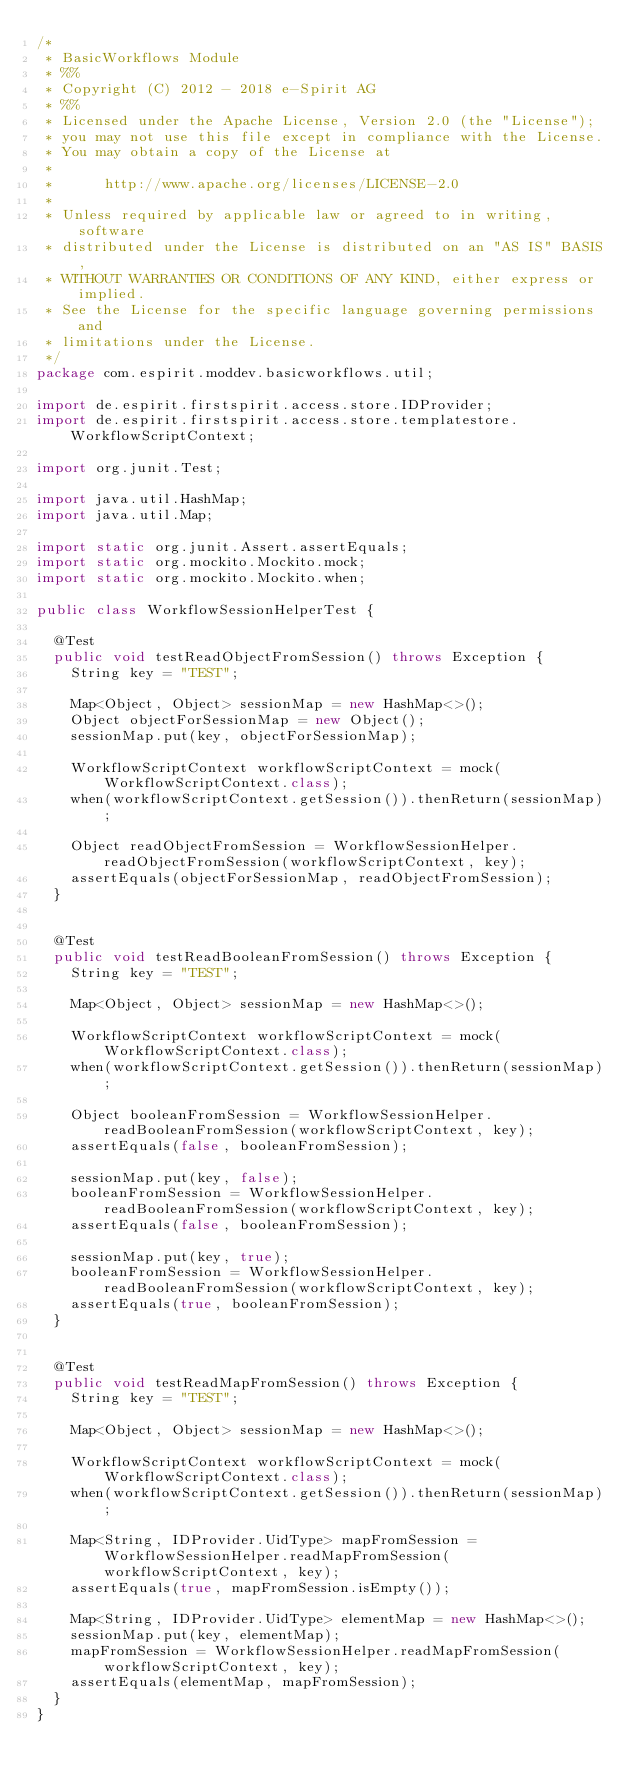<code> <loc_0><loc_0><loc_500><loc_500><_Java_>/*
 * BasicWorkflows Module
 * %%
 * Copyright (C) 2012 - 2018 e-Spirit AG
 * %%
 * Licensed under the Apache License, Version 2.0 (the "License");
 * you may not use this file except in compliance with the License.
 * You may obtain a copy of the License at
 *
 *      http://www.apache.org/licenses/LICENSE-2.0
 *
 * Unless required by applicable law or agreed to in writing, software
 * distributed under the License is distributed on an "AS IS" BASIS,
 * WITHOUT WARRANTIES OR CONDITIONS OF ANY KIND, either express or implied.
 * See the License for the specific language governing permissions and
 * limitations under the License.
 */
package com.espirit.moddev.basicworkflows.util;

import de.espirit.firstspirit.access.store.IDProvider;
import de.espirit.firstspirit.access.store.templatestore.WorkflowScriptContext;

import org.junit.Test;

import java.util.HashMap;
import java.util.Map;

import static org.junit.Assert.assertEquals;
import static org.mockito.Mockito.mock;
import static org.mockito.Mockito.when;

public class WorkflowSessionHelperTest {

	@Test
	public void testReadObjectFromSession() throws Exception {
		String key = "TEST";

		Map<Object, Object> sessionMap = new HashMap<>();
		Object objectForSessionMap = new Object();
		sessionMap.put(key, objectForSessionMap);

		WorkflowScriptContext workflowScriptContext = mock(WorkflowScriptContext.class);
		when(workflowScriptContext.getSession()).thenReturn(sessionMap);

		Object readObjectFromSession = WorkflowSessionHelper.readObjectFromSession(workflowScriptContext, key);
		assertEquals(objectForSessionMap, readObjectFromSession);
	}


	@Test
	public void testReadBooleanFromSession() throws Exception {
		String key = "TEST";

		Map<Object, Object> sessionMap = new HashMap<>();

		WorkflowScriptContext workflowScriptContext = mock(WorkflowScriptContext.class);
		when(workflowScriptContext.getSession()).thenReturn(sessionMap);

		Object booleanFromSession = WorkflowSessionHelper.readBooleanFromSession(workflowScriptContext, key);
		assertEquals(false, booleanFromSession);

		sessionMap.put(key, false);
		booleanFromSession = WorkflowSessionHelper.readBooleanFromSession(workflowScriptContext, key);
		assertEquals(false, booleanFromSession);

		sessionMap.put(key, true);
		booleanFromSession = WorkflowSessionHelper.readBooleanFromSession(workflowScriptContext, key);
		assertEquals(true, booleanFromSession);
	}


	@Test
	public void testReadMapFromSession() throws Exception {
		String key = "TEST";

		Map<Object, Object> sessionMap = new HashMap<>();

		WorkflowScriptContext workflowScriptContext = mock(WorkflowScriptContext.class);
		when(workflowScriptContext.getSession()).thenReturn(sessionMap);

		Map<String, IDProvider.UidType> mapFromSession = WorkflowSessionHelper.readMapFromSession(workflowScriptContext, key);
		assertEquals(true, mapFromSession.isEmpty());

		Map<String, IDProvider.UidType> elementMap = new HashMap<>();
		sessionMap.put(key, elementMap);
		mapFromSession = WorkflowSessionHelper.readMapFromSession(workflowScriptContext, key);
		assertEquals(elementMap, mapFromSession);
	}
}
</code> 